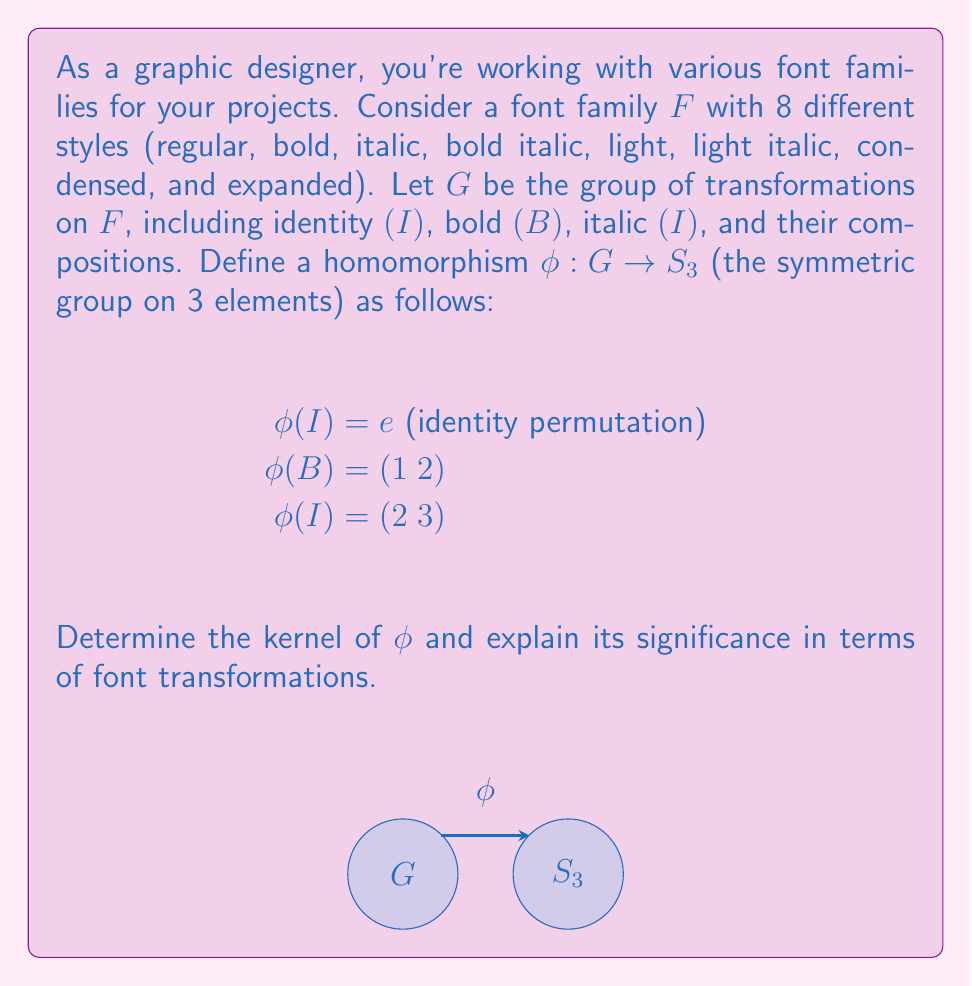Solve this math problem. Let's approach this step-by-step:

1) First, recall that for a group homomorphism φ : G → H, the kernel of φ is defined as:

   ker(φ) = {g ∈ G | φ(g) = e_H}

   where e_H is the identity element of H.

2) In this case, we need to find all elements g ∈ G such that φ(g) = e in S₃.

3) We know φ(I) = e, so I is in the kernel.

4) Now, let's consider the other elements of G:
   
   φ(B) = (1 2)
   φ(I) = (2 3)
   φ(BI) = φ(B) ∘ φ(I) = (1 2) ∘ (2 3) = (1 3 2)
   φ(IB) = φ(I) ∘ φ(B) = (2 3) ∘ (1 2) = (1 2 3)

5) None of these other elements map to e in S₃, so they are not in the kernel.

6) Therefore, ker(φ) = {I}.

7) The significance of this in terms of font transformations:
   The kernel represents the transformations that are "invisible" to the homomorphism φ. In this case, only the identity transformation (I) is in the kernel, which means that all other transformations (B, I, BI, IB) result in a visible change under the mapping φ.

8) This implies that the homomorphism φ is injective (one-to-one), as ker(φ) contains only the identity element. In the context of font transformations, this means that each unique combination of bold and italic transformations maps to a unique permutation in S₃.
Answer: ker(φ) = {I} 